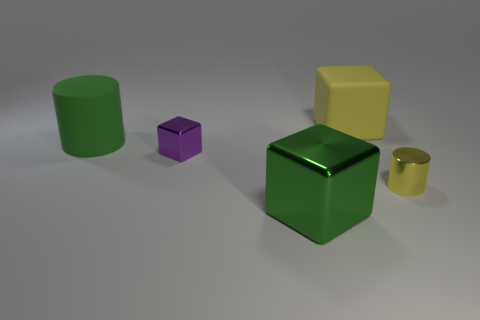Are there any large green cylinders left of the green rubber cylinder?
Offer a terse response. No. How many things are either large cubes behind the metallic cylinder or big rubber objects to the right of the big green cylinder?
Your answer should be compact. 1. What number of large cubes have the same color as the tiny metallic cylinder?
Provide a succinct answer. 1. What color is the other metallic object that is the same shape as the purple object?
Your response must be concise. Green. The thing that is right of the large metallic object and in front of the purple metal block has what shape?
Your response must be concise. Cylinder. Is the number of yellow metal cylinders greater than the number of cyan cylinders?
Ensure brevity in your answer.  Yes. What is the material of the tiny yellow thing?
Offer a very short reply. Metal. Are there any other things that are the same size as the shiny cylinder?
Give a very brief answer. Yes. The purple shiny thing that is the same shape as the big yellow rubber object is what size?
Offer a terse response. Small. There is a metallic thing that is in front of the tiny yellow metallic cylinder; is there a small shiny cylinder in front of it?
Ensure brevity in your answer.  No. 